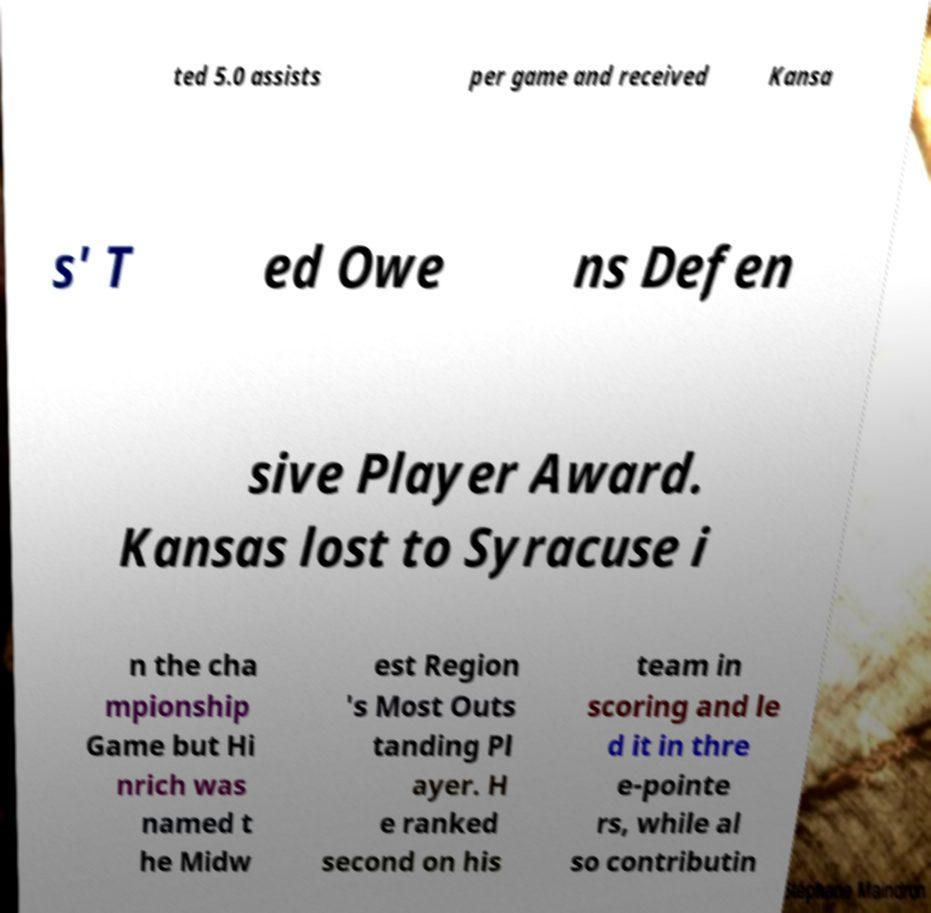I need the written content from this picture converted into text. Can you do that? ted 5.0 assists per game and received Kansa s' T ed Owe ns Defen sive Player Award. Kansas lost to Syracuse i n the cha mpionship Game but Hi nrich was named t he Midw est Region 's Most Outs tanding Pl ayer. H e ranked second on his team in scoring and le d it in thre e-pointe rs, while al so contributin 